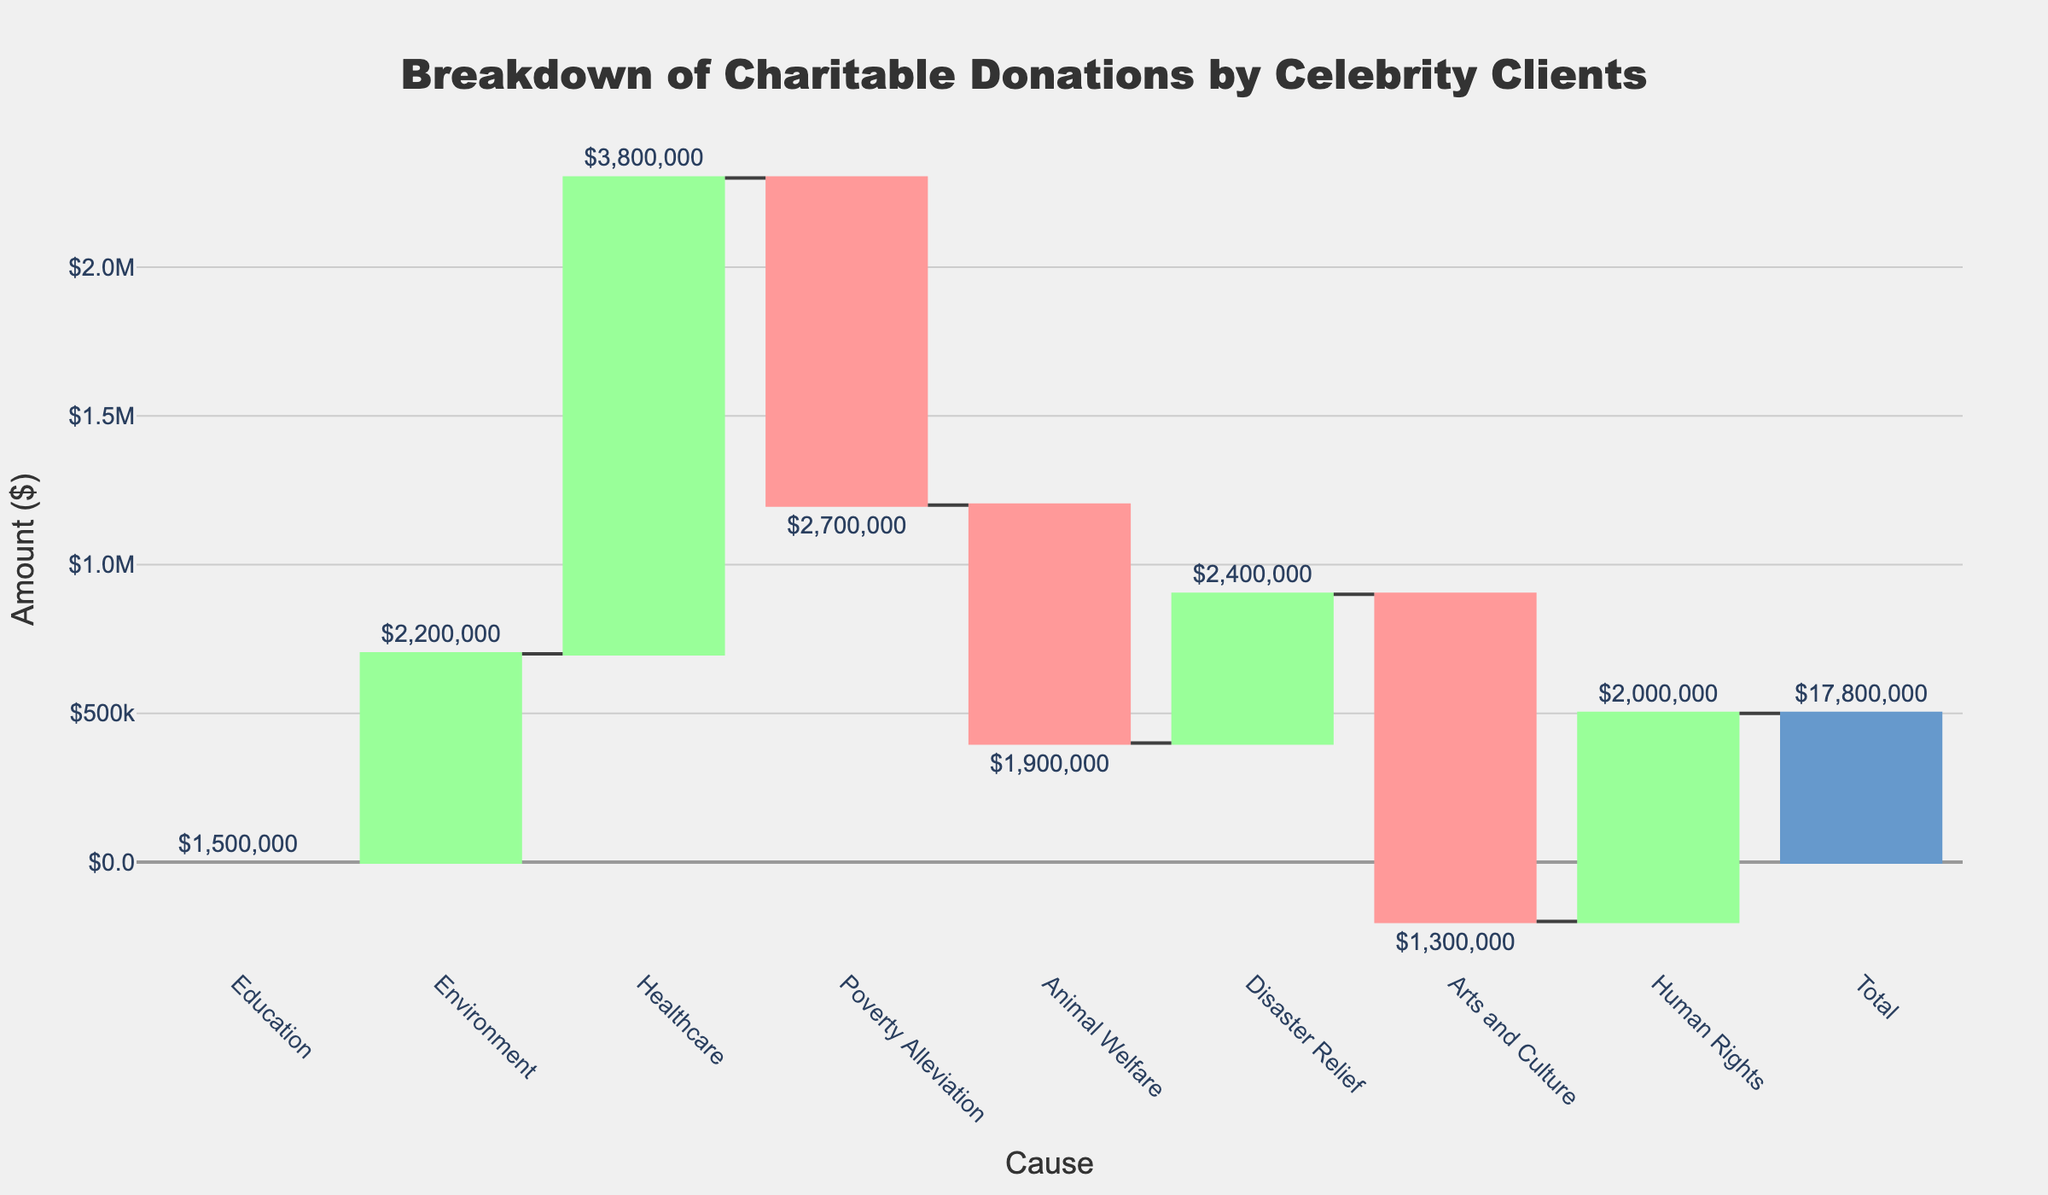What is the total amount of charitable donations? The total donations are shown at the end of the chart with the label "Total," and it is represented by a different color bar. The total amount is $17,800,000.
Answer: $17,800,000 How much was donated to Healthcare? The amount for each cause is labeled on the bars. The bar for Healthcare shows a donation of $3,800,000.
Answer: $3,800,000 Which cause received the least amount of donations? By looking at the heights and labels of the bars, we can see that Arts and Culture received the least amount, at $1,300,000.
Answer: Arts and Culture Which two causes received the highest donations and how do their amounts compare? The bars for Healthcare and Poverty Alleviation are the highest. Healthcare received $3,800,000 and Poverty Alleviation got $2,700,000. So, Healthcare received $1,100,000 more than Poverty Alleviation.
Answer: Healthcare and Poverty Alleviation; $1,100,000 What is the combined total donation amount for Environment and Animal Welfare? The donation for Environment is $2,200,000 and for Animal Welfare is $1,900,000. Their combined total is $2,200,000 + $1,900,000 = $4,100,000.
Answer: $4,100,000 Which cause's donation amount increased the total donations the most? By observing the differences in the heights of the bars, Healthcare shows the largest increase, with a donation amount of $3,800,000.
Answer: Healthcare How does the donation amount for Disaster Relief compare to Human Rights? The donation amount for Disaster Relief is $2,400,000, whereas Human Rights received $2,000,000. Disaster Relief received $400,000 more than Human Rights.
Answer: Disaster Relief What is the cumulative donation amount after adding Environment's donations? The donation for Education is $1,500,000 and for Environment is $2,200,000. Cumulatively, this is $1,500,000 + $2,200,000 = $3,700,000.
Answer: $3,700,000 